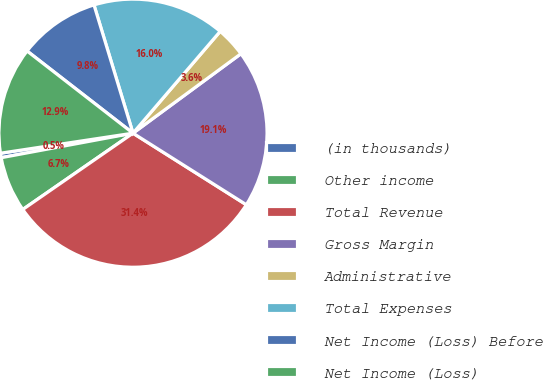Convert chart to OTSL. <chart><loc_0><loc_0><loc_500><loc_500><pie_chart><fcel>(in thousands)<fcel>Other income<fcel>Total Revenue<fcel>Gross Margin<fcel>Administrative<fcel>Total Expenses<fcel>Net Income (Loss) Before<fcel>Net Income (Loss)<nl><fcel>0.54%<fcel>6.71%<fcel>31.4%<fcel>19.06%<fcel>3.63%<fcel>15.97%<fcel>9.8%<fcel>12.89%<nl></chart> 